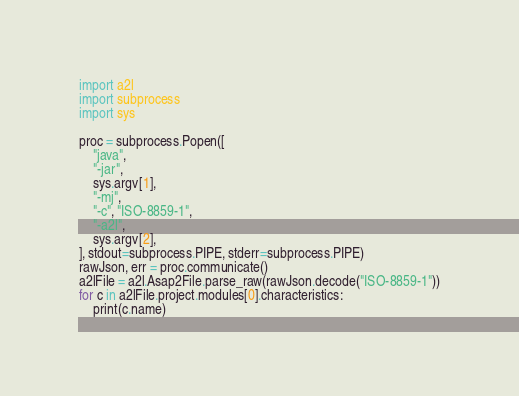Convert code to text. <code><loc_0><loc_0><loc_500><loc_500><_Python_>import a2l
import subprocess
import sys

proc = subprocess.Popen([
    "java",
    "-jar",
    sys.argv[1],
    "-mj",
    "-c", "ISO-8859-1",
    "-a2l",
    sys.argv[2],
], stdout=subprocess.PIPE, stderr=subprocess.PIPE)
rawJson, err = proc.communicate()
a2lFile = a2l.Asap2File.parse_raw(rawJson.decode("ISO-8859-1"))
for c in a2lFile.project.modules[0].characteristics:
    print(c.name)</code> 